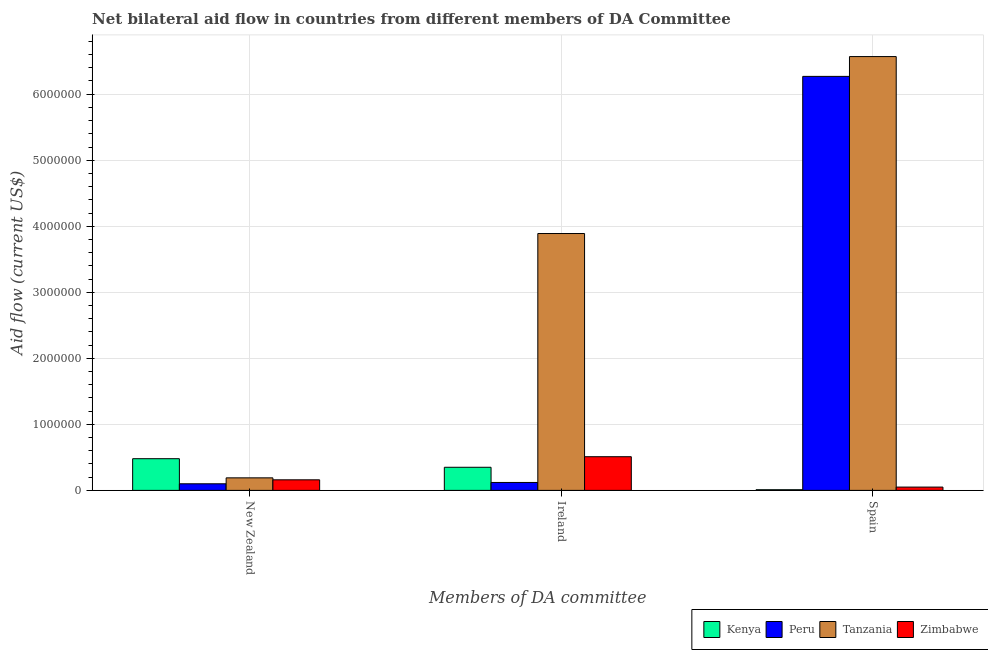How many groups of bars are there?
Ensure brevity in your answer.  3. Are the number of bars per tick equal to the number of legend labels?
Make the answer very short. Yes. How many bars are there on the 1st tick from the left?
Give a very brief answer. 4. What is the label of the 3rd group of bars from the left?
Give a very brief answer. Spain. What is the amount of aid provided by ireland in Peru?
Your answer should be compact. 1.20e+05. Across all countries, what is the maximum amount of aid provided by ireland?
Give a very brief answer. 3.89e+06. Across all countries, what is the minimum amount of aid provided by new zealand?
Your answer should be very brief. 1.00e+05. In which country was the amount of aid provided by ireland maximum?
Ensure brevity in your answer.  Tanzania. What is the total amount of aid provided by ireland in the graph?
Provide a succinct answer. 4.87e+06. What is the difference between the amount of aid provided by spain in Kenya and that in Zimbabwe?
Offer a very short reply. -4.00e+04. What is the difference between the amount of aid provided by spain in Zimbabwe and the amount of aid provided by ireland in Peru?
Your answer should be very brief. -7.00e+04. What is the average amount of aid provided by spain per country?
Give a very brief answer. 3.22e+06. What is the difference between the amount of aid provided by ireland and amount of aid provided by new zealand in Zimbabwe?
Provide a short and direct response. 3.50e+05. What is the ratio of the amount of aid provided by new zealand in Tanzania to that in Zimbabwe?
Ensure brevity in your answer.  1.19. Is the difference between the amount of aid provided by ireland in Peru and Zimbabwe greater than the difference between the amount of aid provided by new zealand in Peru and Zimbabwe?
Ensure brevity in your answer.  No. What is the difference between the highest and the second highest amount of aid provided by ireland?
Give a very brief answer. 3.38e+06. What is the difference between the highest and the lowest amount of aid provided by ireland?
Provide a short and direct response. 3.77e+06. In how many countries, is the amount of aid provided by ireland greater than the average amount of aid provided by ireland taken over all countries?
Keep it short and to the point. 1. What does the 4th bar from the left in New Zealand represents?
Your response must be concise. Zimbabwe. What does the 4th bar from the right in Ireland represents?
Your response must be concise. Kenya. What is the difference between two consecutive major ticks on the Y-axis?
Offer a terse response. 1.00e+06. Does the graph contain grids?
Give a very brief answer. Yes. How are the legend labels stacked?
Provide a succinct answer. Horizontal. What is the title of the graph?
Offer a terse response. Net bilateral aid flow in countries from different members of DA Committee. What is the label or title of the X-axis?
Offer a very short reply. Members of DA committee. What is the Aid flow (current US$) of Kenya in New Zealand?
Offer a terse response. 4.80e+05. What is the Aid flow (current US$) of Peru in New Zealand?
Your answer should be very brief. 1.00e+05. What is the Aid flow (current US$) of Peru in Ireland?
Give a very brief answer. 1.20e+05. What is the Aid flow (current US$) in Tanzania in Ireland?
Provide a succinct answer. 3.89e+06. What is the Aid flow (current US$) of Zimbabwe in Ireland?
Make the answer very short. 5.10e+05. What is the Aid flow (current US$) in Kenya in Spain?
Provide a short and direct response. 10000. What is the Aid flow (current US$) of Peru in Spain?
Provide a succinct answer. 6.27e+06. What is the Aid flow (current US$) of Tanzania in Spain?
Offer a terse response. 6.57e+06. What is the Aid flow (current US$) of Zimbabwe in Spain?
Offer a very short reply. 5.00e+04. Across all Members of DA committee, what is the maximum Aid flow (current US$) in Peru?
Keep it short and to the point. 6.27e+06. Across all Members of DA committee, what is the maximum Aid flow (current US$) in Tanzania?
Ensure brevity in your answer.  6.57e+06. Across all Members of DA committee, what is the maximum Aid flow (current US$) in Zimbabwe?
Your response must be concise. 5.10e+05. Across all Members of DA committee, what is the minimum Aid flow (current US$) of Kenya?
Offer a terse response. 10000. Across all Members of DA committee, what is the minimum Aid flow (current US$) in Zimbabwe?
Your answer should be compact. 5.00e+04. What is the total Aid flow (current US$) in Kenya in the graph?
Offer a very short reply. 8.40e+05. What is the total Aid flow (current US$) in Peru in the graph?
Your response must be concise. 6.49e+06. What is the total Aid flow (current US$) of Tanzania in the graph?
Your response must be concise. 1.06e+07. What is the total Aid flow (current US$) of Zimbabwe in the graph?
Your answer should be very brief. 7.20e+05. What is the difference between the Aid flow (current US$) in Tanzania in New Zealand and that in Ireland?
Keep it short and to the point. -3.70e+06. What is the difference between the Aid flow (current US$) in Zimbabwe in New Zealand and that in Ireland?
Provide a succinct answer. -3.50e+05. What is the difference between the Aid flow (current US$) of Peru in New Zealand and that in Spain?
Make the answer very short. -6.17e+06. What is the difference between the Aid flow (current US$) of Tanzania in New Zealand and that in Spain?
Offer a very short reply. -6.38e+06. What is the difference between the Aid flow (current US$) in Zimbabwe in New Zealand and that in Spain?
Offer a very short reply. 1.10e+05. What is the difference between the Aid flow (current US$) of Kenya in Ireland and that in Spain?
Your answer should be very brief. 3.40e+05. What is the difference between the Aid flow (current US$) of Peru in Ireland and that in Spain?
Offer a very short reply. -6.15e+06. What is the difference between the Aid flow (current US$) in Tanzania in Ireland and that in Spain?
Your answer should be compact. -2.68e+06. What is the difference between the Aid flow (current US$) of Kenya in New Zealand and the Aid flow (current US$) of Tanzania in Ireland?
Provide a succinct answer. -3.41e+06. What is the difference between the Aid flow (current US$) of Peru in New Zealand and the Aid flow (current US$) of Tanzania in Ireland?
Your response must be concise. -3.79e+06. What is the difference between the Aid flow (current US$) in Peru in New Zealand and the Aid flow (current US$) in Zimbabwe in Ireland?
Your response must be concise. -4.10e+05. What is the difference between the Aid flow (current US$) in Tanzania in New Zealand and the Aid flow (current US$) in Zimbabwe in Ireland?
Provide a succinct answer. -3.20e+05. What is the difference between the Aid flow (current US$) of Kenya in New Zealand and the Aid flow (current US$) of Peru in Spain?
Provide a short and direct response. -5.79e+06. What is the difference between the Aid flow (current US$) in Kenya in New Zealand and the Aid flow (current US$) in Tanzania in Spain?
Keep it short and to the point. -6.09e+06. What is the difference between the Aid flow (current US$) of Peru in New Zealand and the Aid flow (current US$) of Tanzania in Spain?
Offer a very short reply. -6.47e+06. What is the difference between the Aid flow (current US$) in Tanzania in New Zealand and the Aid flow (current US$) in Zimbabwe in Spain?
Keep it short and to the point. 1.40e+05. What is the difference between the Aid flow (current US$) of Kenya in Ireland and the Aid flow (current US$) of Peru in Spain?
Your answer should be very brief. -5.92e+06. What is the difference between the Aid flow (current US$) in Kenya in Ireland and the Aid flow (current US$) in Tanzania in Spain?
Provide a short and direct response. -6.22e+06. What is the difference between the Aid flow (current US$) of Kenya in Ireland and the Aid flow (current US$) of Zimbabwe in Spain?
Ensure brevity in your answer.  3.00e+05. What is the difference between the Aid flow (current US$) of Peru in Ireland and the Aid flow (current US$) of Tanzania in Spain?
Your response must be concise. -6.45e+06. What is the difference between the Aid flow (current US$) of Tanzania in Ireland and the Aid flow (current US$) of Zimbabwe in Spain?
Your answer should be compact. 3.84e+06. What is the average Aid flow (current US$) of Peru per Members of DA committee?
Your answer should be compact. 2.16e+06. What is the average Aid flow (current US$) in Tanzania per Members of DA committee?
Give a very brief answer. 3.55e+06. What is the difference between the Aid flow (current US$) in Kenya and Aid flow (current US$) in Peru in New Zealand?
Make the answer very short. 3.80e+05. What is the difference between the Aid flow (current US$) of Kenya and Aid flow (current US$) of Zimbabwe in New Zealand?
Your answer should be compact. 3.20e+05. What is the difference between the Aid flow (current US$) in Tanzania and Aid flow (current US$) in Zimbabwe in New Zealand?
Give a very brief answer. 3.00e+04. What is the difference between the Aid flow (current US$) of Kenya and Aid flow (current US$) of Tanzania in Ireland?
Ensure brevity in your answer.  -3.54e+06. What is the difference between the Aid flow (current US$) in Kenya and Aid flow (current US$) in Zimbabwe in Ireland?
Ensure brevity in your answer.  -1.60e+05. What is the difference between the Aid flow (current US$) in Peru and Aid flow (current US$) in Tanzania in Ireland?
Keep it short and to the point. -3.77e+06. What is the difference between the Aid flow (current US$) in Peru and Aid flow (current US$) in Zimbabwe in Ireland?
Give a very brief answer. -3.90e+05. What is the difference between the Aid flow (current US$) of Tanzania and Aid flow (current US$) of Zimbabwe in Ireland?
Make the answer very short. 3.38e+06. What is the difference between the Aid flow (current US$) in Kenya and Aid flow (current US$) in Peru in Spain?
Offer a very short reply. -6.26e+06. What is the difference between the Aid flow (current US$) in Kenya and Aid flow (current US$) in Tanzania in Spain?
Your answer should be very brief. -6.56e+06. What is the difference between the Aid flow (current US$) in Peru and Aid flow (current US$) in Tanzania in Spain?
Give a very brief answer. -3.00e+05. What is the difference between the Aid flow (current US$) of Peru and Aid flow (current US$) of Zimbabwe in Spain?
Give a very brief answer. 6.22e+06. What is the difference between the Aid flow (current US$) in Tanzania and Aid flow (current US$) in Zimbabwe in Spain?
Keep it short and to the point. 6.52e+06. What is the ratio of the Aid flow (current US$) in Kenya in New Zealand to that in Ireland?
Ensure brevity in your answer.  1.37. What is the ratio of the Aid flow (current US$) of Peru in New Zealand to that in Ireland?
Your response must be concise. 0.83. What is the ratio of the Aid flow (current US$) in Tanzania in New Zealand to that in Ireland?
Provide a succinct answer. 0.05. What is the ratio of the Aid flow (current US$) of Zimbabwe in New Zealand to that in Ireland?
Keep it short and to the point. 0.31. What is the ratio of the Aid flow (current US$) of Kenya in New Zealand to that in Spain?
Provide a succinct answer. 48. What is the ratio of the Aid flow (current US$) of Peru in New Zealand to that in Spain?
Give a very brief answer. 0.02. What is the ratio of the Aid flow (current US$) of Tanzania in New Zealand to that in Spain?
Your response must be concise. 0.03. What is the ratio of the Aid flow (current US$) in Peru in Ireland to that in Spain?
Provide a succinct answer. 0.02. What is the ratio of the Aid flow (current US$) of Tanzania in Ireland to that in Spain?
Ensure brevity in your answer.  0.59. What is the ratio of the Aid flow (current US$) in Zimbabwe in Ireland to that in Spain?
Keep it short and to the point. 10.2. What is the difference between the highest and the second highest Aid flow (current US$) of Kenya?
Keep it short and to the point. 1.30e+05. What is the difference between the highest and the second highest Aid flow (current US$) in Peru?
Make the answer very short. 6.15e+06. What is the difference between the highest and the second highest Aid flow (current US$) in Tanzania?
Offer a terse response. 2.68e+06. What is the difference between the highest and the second highest Aid flow (current US$) in Zimbabwe?
Your response must be concise. 3.50e+05. What is the difference between the highest and the lowest Aid flow (current US$) in Peru?
Provide a short and direct response. 6.17e+06. What is the difference between the highest and the lowest Aid flow (current US$) in Tanzania?
Ensure brevity in your answer.  6.38e+06. 